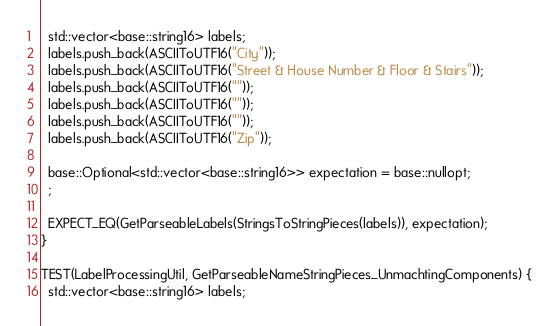Convert code to text. <code><loc_0><loc_0><loc_500><loc_500><_C++_>  std::vector<base::string16> labels;
  labels.push_back(ASCIIToUTF16("City"));
  labels.push_back(ASCIIToUTF16("Street & House Number & Floor & Stairs"));
  labels.push_back(ASCIIToUTF16(""));
  labels.push_back(ASCIIToUTF16(""));
  labels.push_back(ASCIIToUTF16(""));
  labels.push_back(ASCIIToUTF16("Zip"));

  base::Optional<std::vector<base::string16>> expectation = base::nullopt;
  ;

  EXPECT_EQ(GetParseableLabels(StringsToStringPieces(labels)), expectation);
}

TEST(LabelProcessingUtil, GetParseableNameStringPieces_UnmachtingComponents) {
  std::vector<base::string16> labels;</code> 